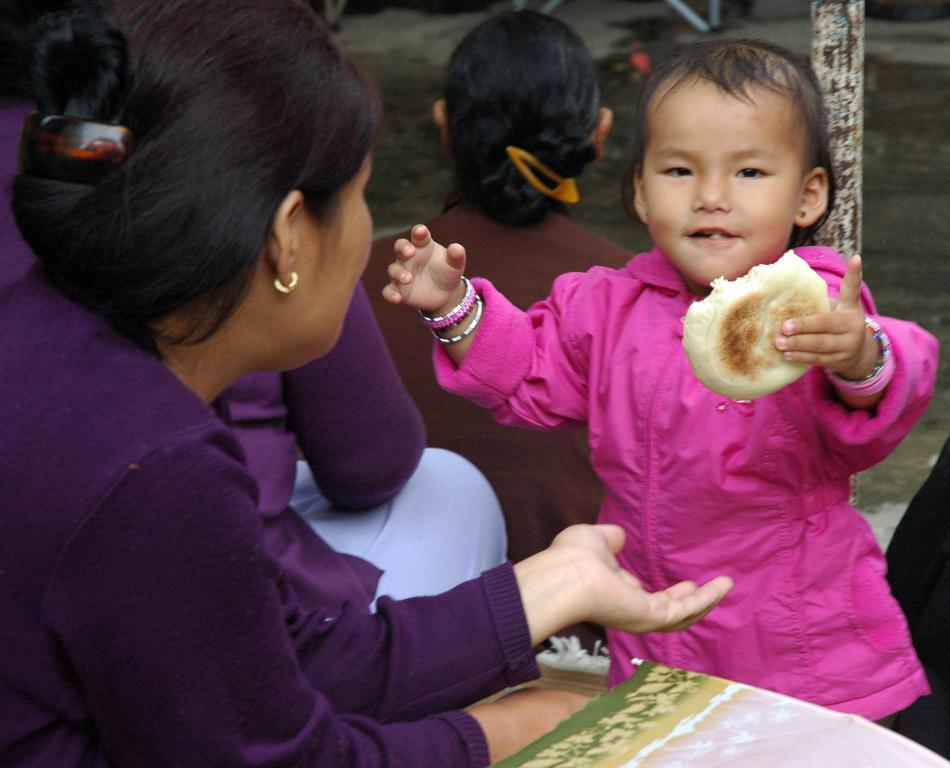How many people are in the image? There are people in the image, but the exact number is not specified. What is the child holding in one hand? The child is holding a food item in one hand. What can be seen in the image besides the people? There is a wooden pole and an object in the bottom right corner of the image. What type of wax can be seen melting on the sidewalk in the image? There is no wax or sidewalk present in the image. How many chairs are visible in the image? There is no mention of chairs in the image. 